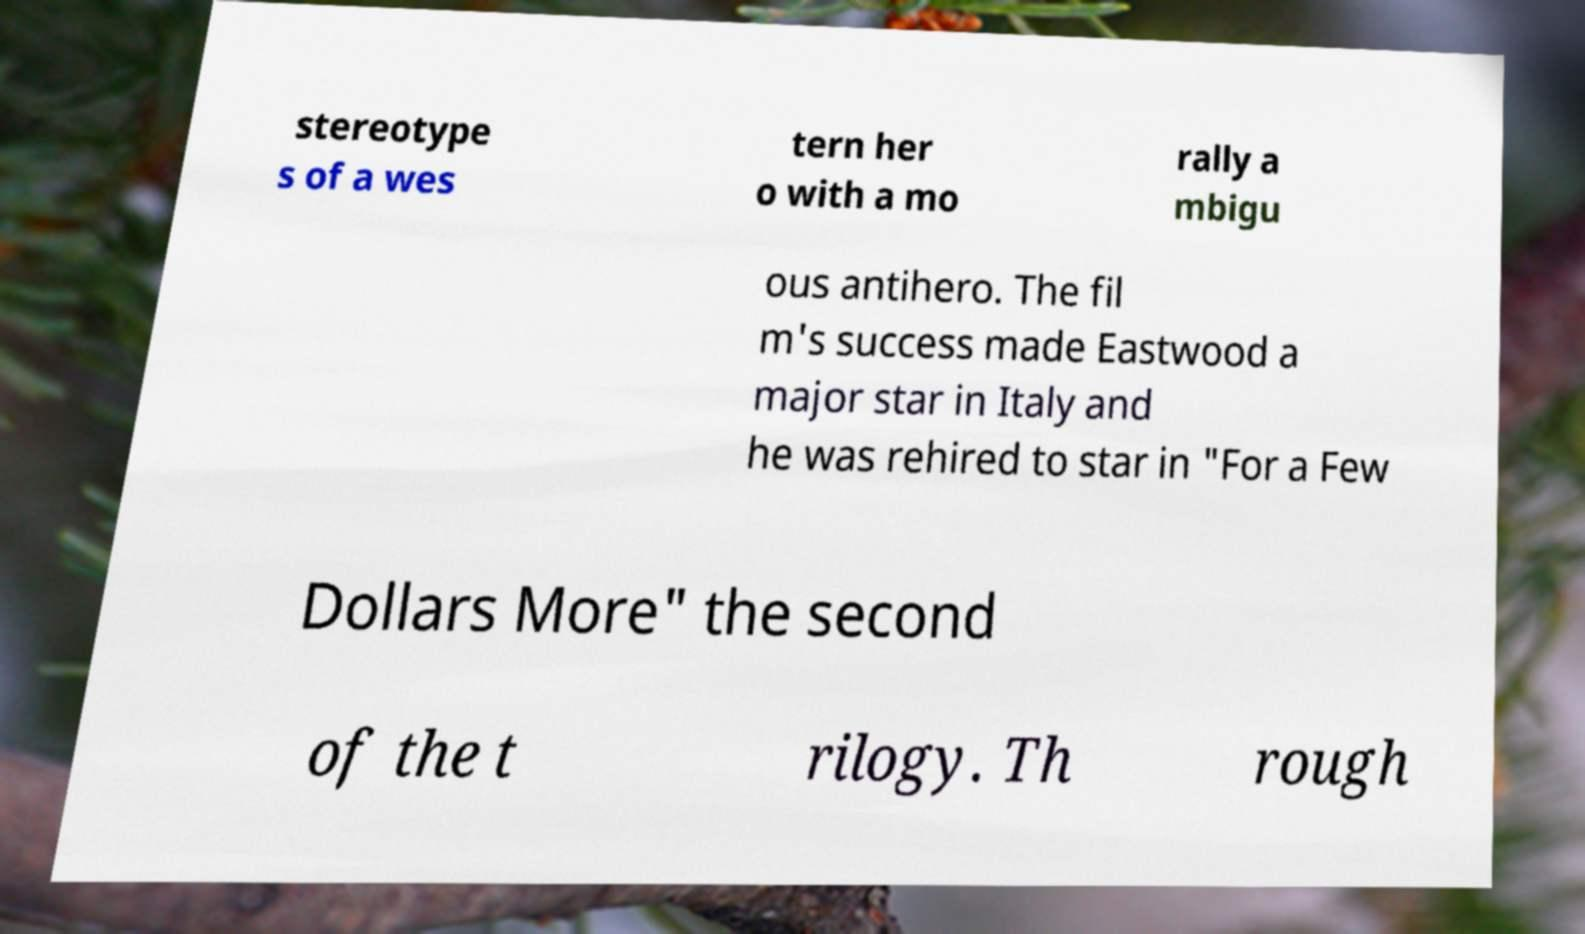What messages or text are displayed in this image? I need them in a readable, typed format. stereotype s of a wes tern her o with a mo rally a mbigu ous antihero. The fil m's success made Eastwood a major star in Italy and he was rehired to star in "For a Few Dollars More" the second of the t rilogy. Th rough 